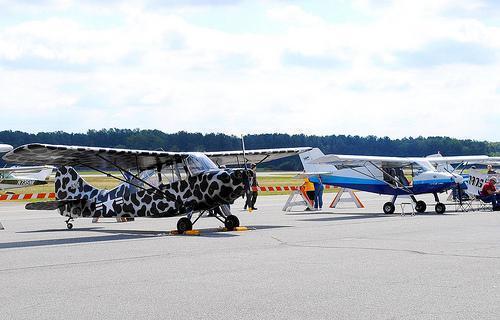How many airplanes are shown here?
Give a very brief answer. 3. 